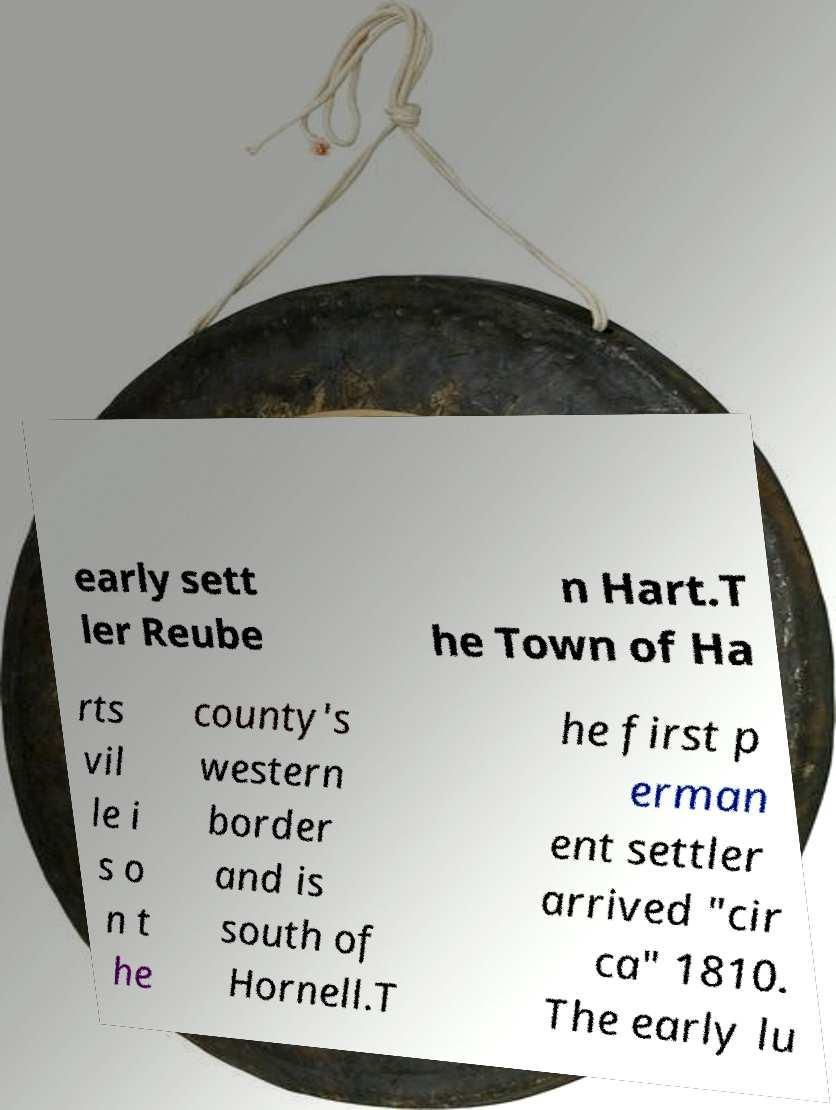Could you assist in decoding the text presented in this image and type it out clearly? early sett ler Reube n Hart.T he Town of Ha rts vil le i s o n t he county's western border and is south of Hornell.T he first p erman ent settler arrived "cir ca" 1810. The early lu 